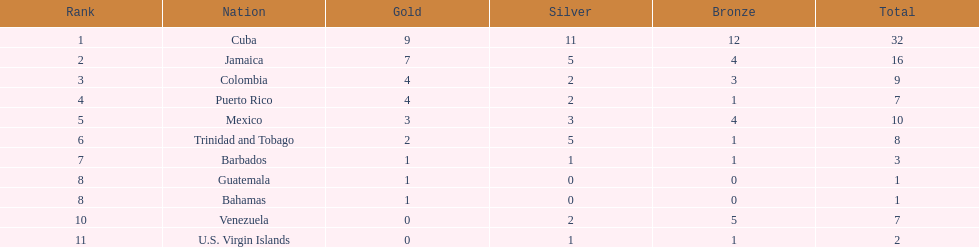Who had more silvers? colmbia or the bahamas Colombia. 